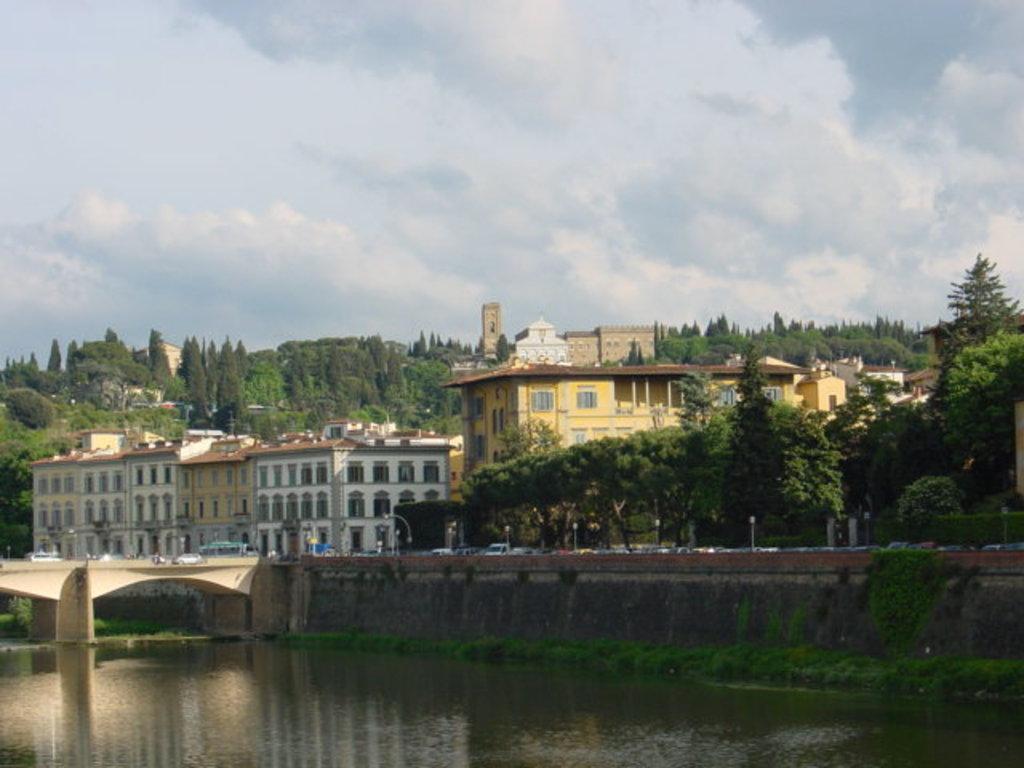Describe this image in one or two sentences. In this image at the bottom we can see water and plants. We can see vehicles on the road and bridge and there are street lights, buildings, trees and poles. In the background there are trees, buildings and clouds in the sky. 